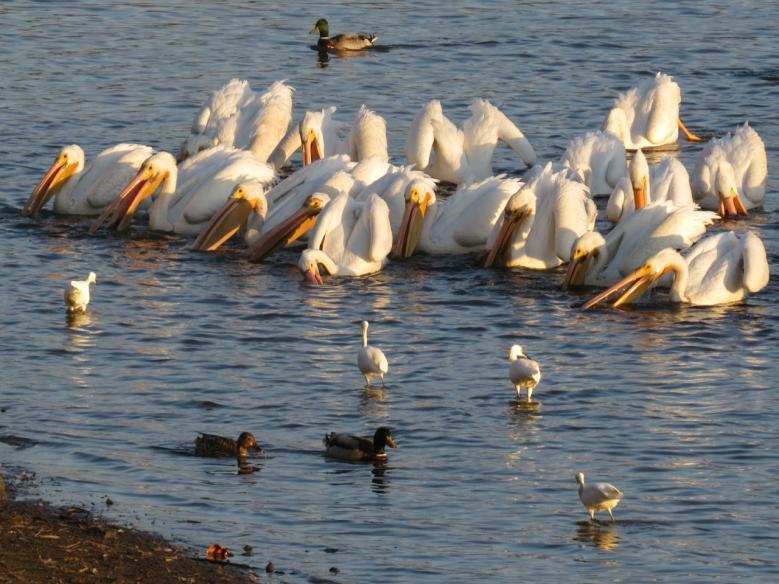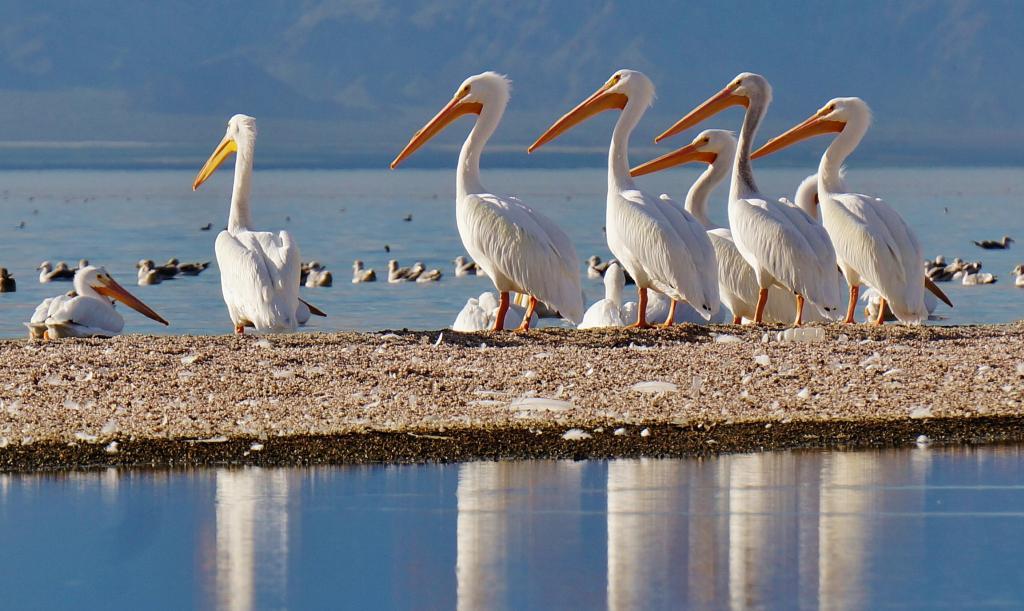The first image is the image on the left, the second image is the image on the right. Analyze the images presented: Is the assertion "An expanse of sandbar is visible under the pelicans." valid? Answer yes or no. Yes. 